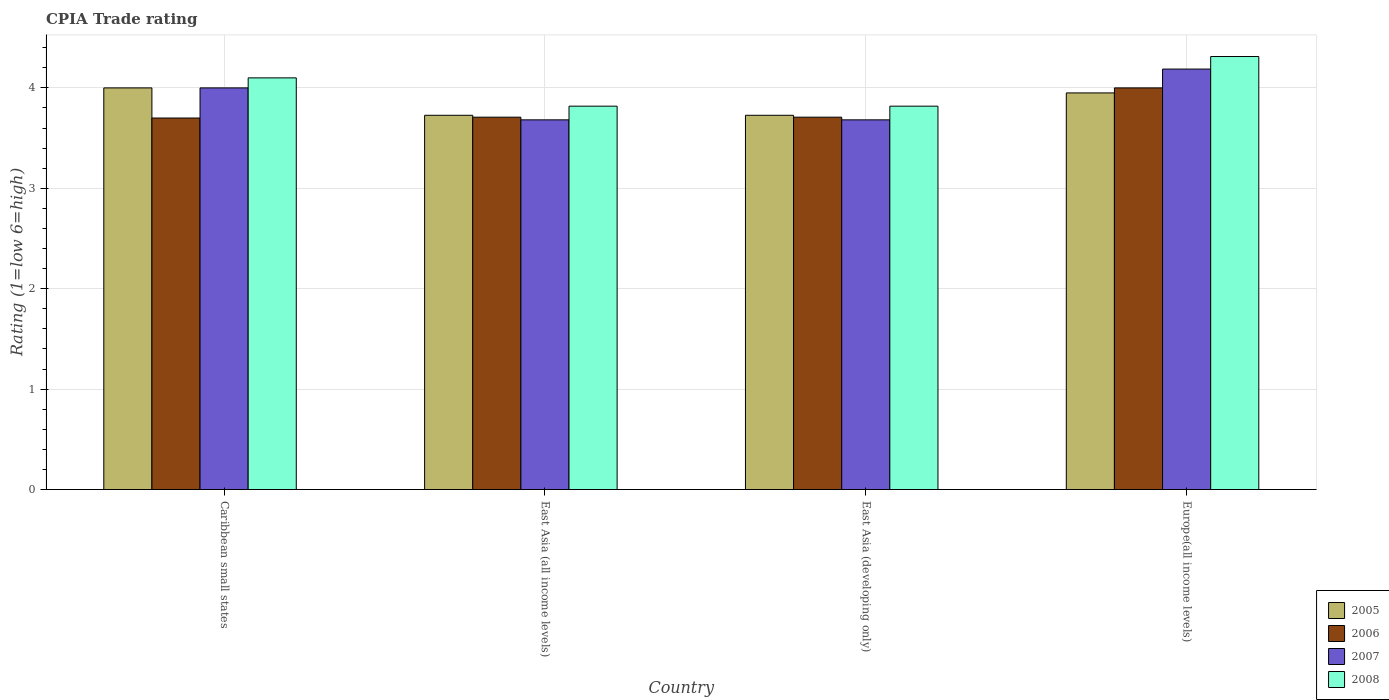Are the number of bars on each tick of the X-axis equal?
Your response must be concise. Yes. How many bars are there on the 3rd tick from the left?
Your answer should be very brief. 4. How many bars are there on the 3rd tick from the right?
Make the answer very short. 4. What is the label of the 1st group of bars from the left?
Give a very brief answer. Caribbean small states. In how many cases, is the number of bars for a given country not equal to the number of legend labels?
Offer a very short reply. 0. What is the CPIA rating in 2006 in East Asia (developing only)?
Your answer should be compact. 3.71. Across all countries, what is the maximum CPIA rating in 2005?
Keep it short and to the point. 4. Across all countries, what is the minimum CPIA rating in 2007?
Offer a terse response. 3.68. In which country was the CPIA rating in 2006 maximum?
Make the answer very short. Europe(all income levels). In which country was the CPIA rating in 2007 minimum?
Your answer should be very brief. East Asia (all income levels). What is the total CPIA rating in 2006 in the graph?
Your response must be concise. 15.12. What is the difference between the CPIA rating in 2007 in East Asia (all income levels) and that in Europe(all income levels)?
Give a very brief answer. -0.51. What is the difference between the CPIA rating in 2005 in Europe(all income levels) and the CPIA rating in 2007 in East Asia (all income levels)?
Your answer should be very brief. 0.27. What is the average CPIA rating in 2005 per country?
Your answer should be very brief. 3.85. What is the difference between the CPIA rating of/in 2005 and CPIA rating of/in 2007 in Europe(all income levels)?
Your answer should be compact. -0.24. Is the difference between the CPIA rating in 2005 in East Asia (developing only) and Europe(all income levels) greater than the difference between the CPIA rating in 2007 in East Asia (developing only) and Europe(all income levels)?
Provide a short and direct response. Yes. What is the difference between the highest and the second highest CPIA rating in 2007?
Your answer should be compact. -0.51. What is the difference between the highest and the lowest CPIA rating in 2008?
Keep it short and to the point. 0.49. Is it the case that in every country, the sum of the CPIA rating in 2008 and CPIA rating in 2007 is greater than the sum of CPIA rating in 2006 and CPIA rating in 2005?
Offer a terse response. No. Is it the case that in every country, the sum of the CPIA rating in 2006 and CPIA rating in 2005 is greater than the CPIA rating in 2007?
Make the answer very short. Yes. How many bars are there?
Ensure brevity in your answer.  16. Are all the bars in the graph horizontal?
Your answer should be very brief. No. How many countries are there in the graph?
Make the answer very short. 4. What is the difference between two consecutive major ticks on the Y-axis?
Your answer should be compact. 1. Are the values on the major ticks of Y-axis written in scientific E-notation?
Your answer should be very brief. No. Does the graph contain any zero values?
Give a very brief answer. No. How many legend labels are there?
Provide a short and direct response. 4. How are the legend labels stacked?
Your response must be concise. Vertical. What is the title of the graph?
Offer a very short reply. CPIA Trade rating. What is the label or title of the Y-axis?
Offer a very short reply. Rating (1=low 6=high). What is the Rating (1=low 6=high) of 2005 in Caribbean small states?
Give a very brief answer. 4. What is the Rating (1=low 6=high) in 2008 in Caribbean small states?
Provide a succinct answer. 4.1. What is the Rating (1=low 6=high) of 2005 in East Asia (all income levels)?
Keep it short and to the point. 3.73. What is the Rating (1=low 6=high) of 2006 in East Asia (all income levels)?
Offer a very short reply. 3.71. What is the Rating (1=low 6=high) of 2007 in East Asia (all income levels)?
Offer a very short reply. 3.68. What is the Rating (1=low 6=high) in 2008 in East Asia (all income levels)?
Offer a terse response. 3.82. What is the Rating (1=low 6=high) in 2005 in East Asia (developing only)?
Offer a very short reply. 3.73. What is the Rating (1=low 6=high) in 2006 in East Asia (developing only)?
Keep it short and to the point. 3.71. What is the Rating (1=low 6=high) in 2007 in East Asia (developing only)?
Ensure brevity in your answer.  3.68. What is the Rating (1=low 6=high) in 2008 in East Asia (developing only)?
Your answer should be very brief. 3.82. What is the Rating (1=low 6=high) in 2005 in Europe(all income levels)?
Your response must be concise. 3.95. What is the Rating (1=low 6=high) of 2007 in Europe(all income levels)?
Provide a short and direct response. 4.19. What is the Rating (1=low 6=high) in 2008 in Europe(all income levels)?
Give a very brief answer. 4.31. Across all countries, what is the maximum Rating (1=low 6=high) in 2006?
Keep it short and to the point. 4. Across all countries, what is the maximum Rating (1=low 6=high) of 2007?
Offer a terse response. 4.19. Across all countries, what is the maximum Rating (1=low 6=high) in 2008?
Offer a very short reply. 4.31. Across all countries, what is the minimum Rating (1=low 6=high) in 2005?
Provide a succinct answer. 3.73. Across all countries, what is the minimum Rating (1=low 6=high) in 2007?
Give a very brief answer. 3.68. Across all countries, what is the minimum Rating (1=low 6=high) of 2008?
Keep it short and to the point. 3.82. What is the total Rating (1=low 6=high) of 2005 in the graph?
Provide a succinct answer. 15.4. What is the total Rating (1=low 6=high) in 2006 in the graph?
Ensure brevity in your answer.  15.12. What is the total Rating (1=low 6=high) in 2007 in the graph?
Offer a very short reply. 15.55. What is the total Rating (1=low 6=high) in 2008 in the graph?
Make the answer very short. 16.05. What is the difference between the Rating (1=low 6=high) in 2005 in Caribbean small states and that in East Asia (all income levels)?
Provide a short and direct response. 0.27. What is the difference between the Rating (1=low 6=high) of 2006 in Caribbean small states and that in East Asia (all income levels)?
Offer a terse response. -0.01. What is the difference between the Rating (1=low 6=high) of 2007 in Caribbean small states and that in East Asia (all income levels)?
Make the answer very short. 0.32. What is the difference between the Rating (1=low 6=high) in 2008 in Caribbean small states and that in East Asia (all income levels)?
Provide a succinct answer. 0.28. What is the difference between the Rating (1=low 6=high) in 2005 in Caribbean small states and that in East Asia (developing only)?
Provide a short and direct response. 0.27. What is the difference between the Rating (1=low 6=high) in 2006 in Caribbean small states and that in East Asia (developing only)?
Keep it short and to the point. -0.01. What is the difference between the Rating (1=low 6=high) of 2007 in Caribbean small states and that in East Asia (developing only)?
Your answer should be very brief. 0.32. What is the difference between the Rating (1=low 6=high) of 2008 in Caribbean small states and that in East Asia (developing only)?
Offer a terse response. 0.28. What is the difference between the Rating (1=low 6=high) of 2005 in Caribbean small states and that in Europe(all income levels)?
Offer a very short reply. 0.05. What is the difference between the Rating (1=low 6=high) of 2006 in Caribbean small states and that in Europe(all income levels)?
Ensure brevity in your answer.  -0.3. What is the difference between the Rating (1=low 6=high) of 2007 in Caribbean small states and that in Europe(all income levels)?
Offer a very short reply. -0.19. What is the difference between the Rating (1=low 6=high) of 2008 in Caribbean small states and that in Europe(all income levels)?
Your response must be concise. -0.21. What is the difference between the Rating (1=low 6=high) in 2005 in East Asia (all income levels) and that in East Asia (developing only)?
Offer a very short reply. 0. What is the difference between the Rating (1=low 6=high) in 2008 in East Asia (all income levels) and that in East Asia (developing only)?
Make the answer very short. 0. What is the difference between the Rating (1=low 6=high) of 2005 in East Asia (all income levels) and that in Europe(all income levels)?
Your answer should be compact. -0.22. What is the difference between the Rating (1=low 6=high) of 2006 in East Asia (all income levels) and that in Europe(all income levels)?
Provide a short and direct response. -0.29. What is the difference between the Rating (1=low 6=high) in 2007 in East Asia (all income levels) and that in Europe(all income levels)?
Ensure brevity in your answer.  -0.51. What is the difference between the Rating (1=low 6=high) of 2008 in East Asia (all income levels) and that in Europe(all income levels)?
Provide a succinct answer. -0.49. What is the difference between the Rating (1=low 6=high) in 2005 in East Asia (developing only) and that in Europe(all income levels)?
Your response must be concise. -0.22. What is the difference between the Rating (1=low 6=high) in 2006 in East Asia (developing only) and that in Europe(all income levels)?
Provide a succinct answer. -0.29. What is the difference between the Rating (1=low 6=high) of 2007 in East Asia (developing only) and that in Europe(all income levels)?
Give a very brief answer. -0.51. What is the difference between the Rating (1=low 6=high) in 2008 in East Asia (developing only) and that in Europe(all income levels)?
Your response must be concise. -0.49. What is the difference between the Rating (1=low 6=high) of 2005 in Caribbean small states and the Rating (1=low 6=high) of 2006 in East Asia (all income levels)?
Your answer should be very brief. 0.29. What is the difference between the Rating (1=low 6=high) of 2005 in Caribbean small states and the Rating (1=low 6=high) of 2007 in East Asia (all income levels)?
Your answer should be very brief. 0.32. What is the difference between the Rating (1=low 6=high) of 2005 in Caribbean small states and the Rating (1=low 6=high) of 2008 in East Asia (all income levels)?
Give a very brief answer. 0.18. What is the difference between the Rating (1=low 6=high) of 2006 in Caribbean small states and the Rating (1=low 6=high) of 2007 in East Asia (all income levels)?
Provide a short and direct response. 0.02. What is the difference between the Rating (1=low 6=high) of 2006 in Caribbean small states and the Rating (1=low 6=high) of 2008 in East Asia (all income levels)?
Offer a very short reply. -0.12. What is the difference between the Rating (1=low 6=high) of 2007 in Caribbean small states and the Rating (1=low 6=high) of 2008 in East Asia (all income levels)?
Provide a succinct answer. 0.18. What is the difference between the Rating (1=low 6=high) in 2005 in Caribbean small states and the Rating (1=low 6=high) in 2006 in East Asia (developing only)?
Give a very brief answer. 0.29. What is the difference between the Rating (1=low 6=high) in 2005 in Caribbean small states and the Rating (1=low 6=high) in 2007 in East Asia (developing only)?
Provide a short and direct response. 0.32. What is the difference between the Rating (1=low 6=high) of 2005 in Caribbean small states and the Rating (1=low 6=high) of 2008 in East Asia (developing only)?
Your answer should be compact. 0.18. What is the difference between the Rating (1=low 6=high) in 2006 in Caribbean small states and the Rating (1=low 6=high) in 2007 in East Asia (developing only)?
Offer a terse response. 0.02. What is the difference between the Rating (1=low 6=high) in 2006 in Caribbean small states and the Rating (1=low 6=high) in 2008 in East Asia (developing only)?
Make the answer very short. -0.12. What is the difference between the Rating (1=low 6=high) of 2007 in Caribbean small states and the Rating (1=low 6=high) of 2008 in East Asia (developing only)?
Give a very brief answer. 0.18. What is the difference between the Rating (1=low 6=high) of 2005 in Caribbean small states and the Rating (1=low 6=high) of 2007 in Europe(all income levels)?
Keep it short and to the point. -0.19. What is the difference between the Rating (1=low 6=high) in 2005 in Caribbean small states and the Rating (1=low 6=high) in 2008 in Europe(all income levels)?
Your answer should be compact. -0.31. What is the difference between the Rating (1=low 6=high) in 2006 in Caribbean small states and the Rating (1=low 6=high) in 2007 in Europe(all income levels)?
Give a very brief answer. -0.49. What is the difference between the Rating (1=low 6=high) of 2006 in Caribbean small states and the Rating (1=low 6=high) of 2008 in Europe(all income levels)?
Provide a succinct answer. -0.61. What is the difference between the Rating (1=low 6=high) in 2007 in Caribbean small states and the Rating (1=low 6=high) in 2008 in Europe(all income levels)?
Your answer should be compact. -0.31. What is the difference between the Rating (1=low 6=high) of 2005 in East Asia (all income levels) and the Rating (1=low 6=high) of 2006 in East Asia (developing only)?
Your response must be concise. 0.02. What is the difference between the Rating (1=low 6=high) in 2005 in East Asia (all income levels) and the Rating (1=low 6=high) in 2007 in East Asia (developing only)?
Provide a succinct answer. 0.05. What is the difference between the Rating (1=low 6=high) in 2005 in East Asia (all income levels) and the Rating (1=low 6=high) in 2008 in East Asia (developing only)?
Give a very brief answer. -0.09. What is the difference between the Rating (1=low 6=high) in 2006 in East Asia (all income levels) and the Rating (1=low 6=high) in 2007 in East Asia (developing only)?
Your answer should be compact. 0.03. What is the difference between the Rating (1=low 6=high) of 2006 in East Asia (all income levels) and the Rating (1=low 6=high) of 2008 in East Asia (developing only)?
Ensure brevity in your answer.  -0.11. What is the difference between the Rating (1=low 6=high) of 2007 in East Asia (all income levels) and the Rating (1=low 6=high) of 2008 in East Asia (developing only)?
Provide a short and direct response. -0.14. What is the difference between the Rating (1=low 6=high) in 2005 in East Asia (all income levels) and the Rating (1=low 6=high) in 2006 in Europe(all income levels)?
Give a very brief answer. -0.27. What is the difference between the Rating (1=low 6=high) in 2005 in East Asia (all income levels) and the Rating (1=low 6=high) in 2007 in Europe(all income levels)?
Your answer should be compact. -0.46. What is the difference between the Rating (1=low 6=high) of 2005 in East Asia (all income levels) and the Rating (1=low 6=high) of 2008 in Europe(all income levels)?
Keep it short and to the point. -0.59. What is the difference between the Rating (1=low 6=high) in 2006 in East Asia (all income levels) and the Rating (1=low 6=high) in 2007 in Europe(all income levels)?
Make the answer very short. -0.48. What is the difference between the Rating (1=low 6=high) of 2006 in East Asia (all income levels) and the Rating (1=low 6=high) of 2008 in Europe(all income levels)?
Provide a succinct answer. -0.6. What is the difference between the Rating (1=low 6=high) of 2007 in East Asia (all income levels) and the Rating (1=low 6=high) of 2008 in Europe(all income levels)?
Give a very brief answer. -0.63. What is the difference between the Rating (1=low 6=high) of 2005 in East Asia (developing only) and the Rating (1=low 6=high) of 2006 in Europe(all income levels)?
Ensure brevity in your answer.  -0.27. What is the difference between the Rating (1=low 6=high) of 2005 in East Asia (developing only) and the Rating (1=low 6=high) of 2007 in Europe(all income levels)?
Ensure brevity in your answer.  -0.46. What is the difference between the Rating (1=low 6=high) of 2005 in East Asia (developing only) and the Rating (1=low 6=high) of 2008 in Europe(all income levels)?
Offer a terse response. -0.59. What is the difference between the Rating (1=low 6=high) in 2006 in East Asia (developing only) and the Rating (1=low 6=high) in 2007 in Europe(all income levels)?
Your response must be concise. -0.48. What is the difference between the Rating (1=low 6=high) of 2006 in East Asia (developing only) and the Rating (1=low 6=high) of 2008 in Europe(all income levels)?
Your answer should be compact. -0.6. What is the difference between the Rating (1=low 6=high) of 2007 in East Asia (developing only) and the Rating (1=low 6=high) of 2008 in Europe(all income levels)?
Give a very brief answer. -0.63. What is the average Rating (1=low 6=high) in 2005 per country?
Provide a short and direct response. 3.85. What is the average Rating (1=low 6=high) of 2006 per country?
Your response must be concise. 3.78. What is the average Rating (1=low 6=high) in 2007 per country?
Make the answer very short. 3.89. What is the average Rating (1=low 6=high) in 2008 per country?
Provide a short and direct response. 4.01. What is the difference between the Rating (1=low 6=high) of 2005 and Rating (1=low 6=high) of 2006 in Caribbean small states?
Provide a succinct answer. 0.3. What is the difference between the Rating (1=low 6=high) in 2005 and Rating (1=low 6=high) in 2007 in Caribbean small states?
Your answer should be compact. 0. What is the difference between the Rating (1=low 6=high) of 2005 and Rating (1=low 6=high) of 2008 in Caribbean small states?
Your answer should be very brief. -0.1. What is the difference between the Rating (1=low 6=high) in 2005 and Rating (1=low 6=high) in 2006 in East Asia (all income levels)?
Ensure brevity in your answer.  0.02. What is the difference between the Rating (1=low 6=high) of 2005 and Rating (1=low 6=high) of 2007 in East Asia (all income levels)?
Your answer should be very brief. 0.05. What is the difference between the Rating (1=low 6=high) of 2005 and Rating (1=low 6=high) of 2008 in East Asia (all income levels)?
Make the answer very short. -0.09. What is the difference between the Rating (1=low 6=high) of 2006 and Rating (1=low 6=high) of 2007 in East Asia (all income levels)?
Ensure brevity in your answer.  0.03. What is the difference between the Rating (1=low 6=high) of 2006 and Rating (1=low 6=high) of 2008 in East Asia (all income levels)?
Offer a very short reply. -0.11. What is the difference between the Rating (1=low 6=high) of 2007 and Rating (1=low 6=high) of 2008 in East Asia (all income levels)?
Keep it short and to the point. -0.14. What is the difference between the Rating (1=low 6=high) in 2005 and Rating (1=low 6=high) in 2006 in East Asia (developing only)?
Your response must be concise. 0.02. What is the difference between the Rating (1=low 6=high) in 2005 and Rating (1=low 6=high) in 2007 in East Asia (developing only)?
Your response must be concise. 0.05. What is the difference between the Rating (1=low 6=high) in 2005 and Rating (1=low 6=high) in 2008 in East Asia (developing only)?
Your answer should be very brief. -0.09. What is the difference between the Rating (1=low 6=high) in 2006 and Rating (1=low 6=high) in 2007 in East Asia (developing only)?
Provide a short and direct response. 0.03. What is the difference between the Rating (1=low 6=high) in 2006 and Rating (1=low 6=high) in 2008 in East Asia (developing only)?
Make the answer very short. -0.11. What is the difference between the Rating (1=low 6=high) of 2007 and Rating (1=low 6=high) of 2008 in East Asia (developing only)?
Make the answer very short. -0.14. What is the difference between the Rating (1=low 6=high) in 2005 and Rating (1=low 6=high) in 2007 in Europe(all income levels)?
Offer a very short reply. -0.24. What is the difference between the Rating (1=low 6=high) in 2005 and Rating (1=low 6=high) in 2008 in Europe(all income levels)?
Provide a short and direct response. -0.36. What is the difference between the Rating (1=low 6=high) of 2006 and Rating (1=low 6=high) of 2007 in Europe(all income levels)?
Ensure brevity in your answer.  -0.19. What is the difference between the Rating (1=low 6=high) of 2006 and Rating (1=low 6=high) of 2008 in Europe(all income levels)?
Your response must be concise. -0.31. What is the difference between the Rating (1=low 6=high) of 2007 and Rating (1=low 6=high) of 2008 in Europe(all income levels)?
Give a very brief answer. -0.12. What is the ratio of the Rating (1=low 6=high) in 2005 in Caribbean small states to that in East Asia (all income levels)?
Offer a very short reply. 1.07. What is the ratio of the Rating (1=low 6=high) of 2006 in Caribbean small states to that in East Asia (all income levels)?
Make the answer very short. 1. What is the ratio of the Rating (1=low 6=high) of 2007 in Caribbean small states to that in East Asia (all income levels)?
Provide a short and direct response. 1.09. What is the ratio of the Rating (1=low 6=high) in 2008 in Caribbean small states to that in East Asia (all income levels)?
Offer a terse response. 1.07. What is the ratio of the Rating (1=low 6=high) of 2005 in Caribbean small states to that in East Asia (developing only)?
Offer a very short reply. 1.07. What is the ratio of the Rating (1=low 6=high) of 2006 in Caribbean small states to that in East Asia (developing only)?
Make the answer very short. 1. What is the ratio of the Rating (1=low 6=high) of 2007 in Caribbean small states to that in East Asia (developing only)?
Provide a succinct answer. 1.09. What is the ratio of the Rating (1=low 6=high) in 2008 in Caribbean small states to that in East Asia (developing only)?
Make the answer very short. 1.07. What is the ratio of the Rating (1=low 6=high) in 2005 in Caribbean small states to that in Europe(all income levels)?
Offer a very short reply. 1.01. What is the ratio of the Rating (1=low 6=high) of 2006 in Caribbean small states to that in Europe(all income levels)?
Keep it short and to the point. 0.93. What is the ratio of the Rating (1=low 6=high) of 2007 in Caribbean small states to that in Europe(all income levels)?
Keep it short and to the point. 0.96. What is the ratio of the Rating (1=low 6=high) in 2008 in Caribbean small states to that in Europe(all income levels)?
Keep it short and to the point. 0.95. What is the ratio of the Rating (1=low 6=high) of 2007 in East Asia (all income levels) to that in East Asia (developing only)?
Make the answer very short. 1. What is the ratio of the Rating (1=low 6=high) in 2005 in East Asia (all income levels) to that in Europe(all income levels)?
Keep it short and to the point. 0.94. What is the ratio of the Rating (1=low 6=high) of 2006 in East Asia (all income levels) to that in Europe(all income levels)?
Offer a terse response. 0.93. What is the ratio of the Rating (1=low 6=high) in 2007 in East Asia (all income levels) to that in Europe(all income levels)?
Your answer should be very brief. 0.88. What is the ratio of the Rating (1=low 6=high) of 2008 in East Asia (all income levels) to that in Europe(all income levels)?
Provide a short and direct response. 0.89. What is the ratio of the Rating (1=low 6=high) of 2005 in East Asia (developing only) to that in Europe(all income levels)?
Your answer should be compact. 0.94. What is the ratio of the Rating (1=low 6=high) of 2006 in East Asia (developing only) to that in Europe(all income levels)?
Ensure brevity in your answer.  0.93. What is the ratio of the Rating (1=low 6=high) in 2007 in East Asia (developing only) to that in Europe(all income levels)?
Your response must be concise. 0.88. What is the ratio of the Rating (1=low 6=high) in 2008 in East Asia (developing only) to that in Europe(all income levels)?
Offer a terse response. 0.89. What is the difference between the highest and the second highest Rating (1=low 6=high) in 2005?
Offer a terse response. 0.05. What is the difference between the highest and the second highest Rating (1=low 6=high) of 2006?
Your response must be concise. 0.29. What is the difference between the highest and the second highest Rating (1=low 6=high) of 2007?
Your answer should be compact. 0.19. What is the difference between the highest and the second highest Rating (1=low 6=high) in 2008?
Give a very brief answer. 0.21. What is the difference between the highest and the lowest Rating (1=low 6=high) in 2005?
Your answer should be compact. 0.27. What is the difference between the highest and the lowest Rating (1=low 6=high) of 2006?
Keep it short and to the point. 0.3. What is the difference between the highest and the lowest Rating (1=low 6=high) in 2007?
Offer a very short reply. 0.51. What is the difference between the highest and the lowest Rating (1=low 6=high) of 2008?
Offer a terse response. 0.49. 